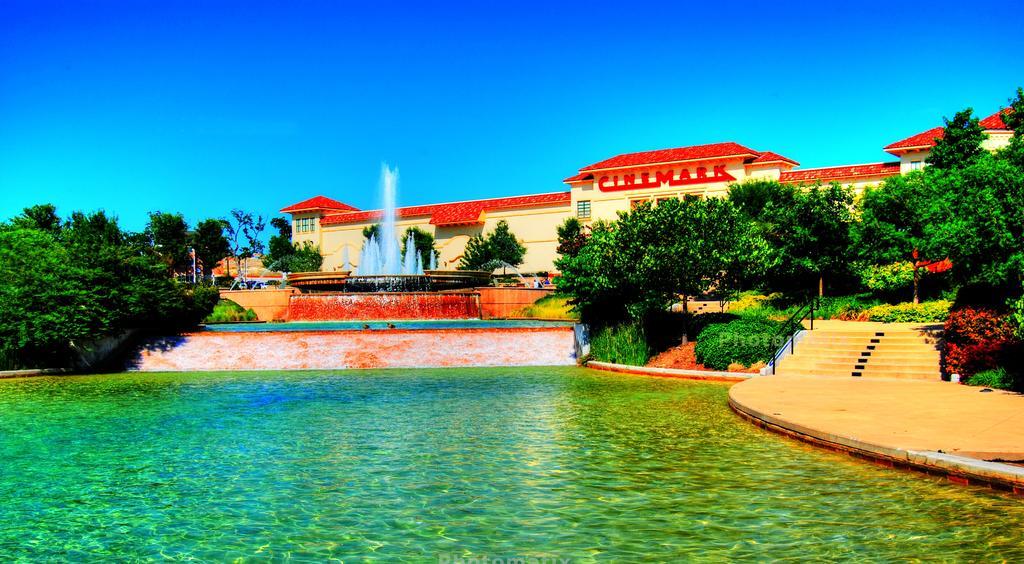Could you give a brief overview of what you see in this image? In this image, we can see so many trees, plants, stairs, rods, water fountains, walkway. Top of the image, there is a clear sky. 